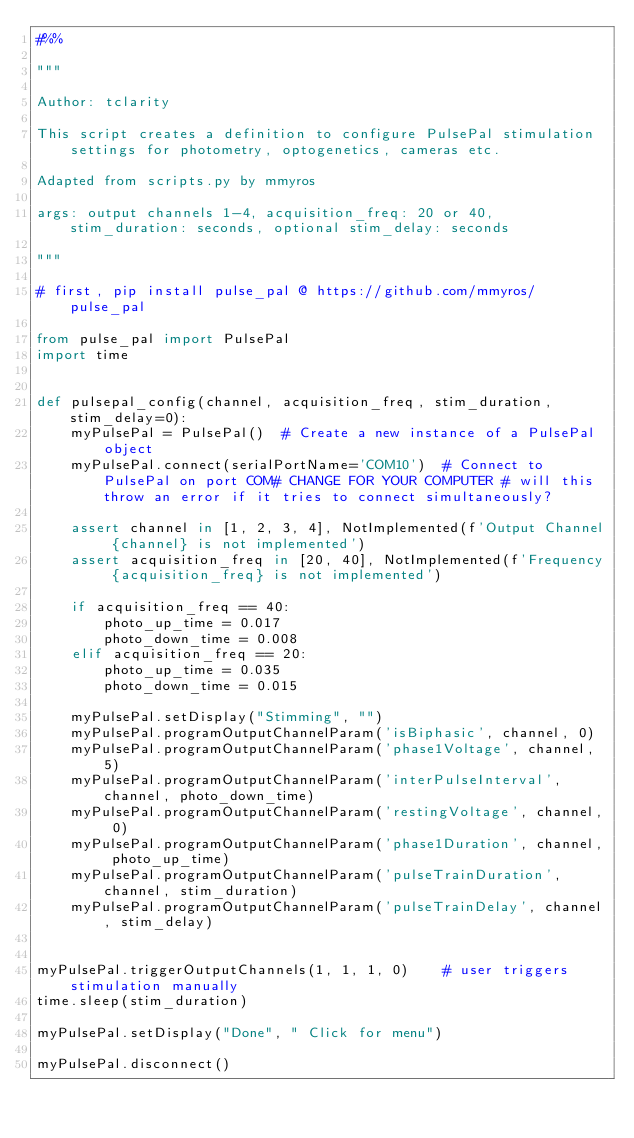<code> <loc_0><loc_0><loc_500><loc_500><_Python_>#%%

"""

Author: tclarity

This script creates a definition to configure PulsePal stimulation settings for photometry, optogenetics, cameras etc.

Adapted from scripts.py by mmyros

args: output channels 1-4, acquisition_freq: 20 or 40, stim_duration: seconds, optional stim_delay: seconds

"""

# first, pip install pulse_pal @ https://github.com/mmyros/pulse_pal

from pulse_pal import PulsePal
import time


def pulsepal_config(channel, acquisition_freq, stim_duration, stim_delay=0):
    myPulsePal = PulsePal()  # Create a new instance of a PulsePal object
    myPulsePal.connect(serialPortName='COM10')  # Connect to PulsePal on port COM# CHANGE FOR YOUR COMPUTER # will this throw an error if it tries to connect simultaneously?

    assert channel in [1, 2, 3, 4], NotImplemented(f'Output Channel {channel} is not implemented')
    assert acquisition_freq in [20, 40], NotImplemented(f'Frequency {acquisition_freq} is not implemented')

    if acquisition_freq == 40:
        photo_up_time = 0.017
        photo_down_time = 0.008
    elif acquisition_freq == 20:
        photo_up_time = 0.035
        photo_down_time = 0.015

    myPulsePal.setDisplay("Stimming", "")
    myPulsePal.programOutputChannelParam('isBiphasic', channel, 0)
    myPulsePal.programOutputChannelParam('phase1Voltage', channel, 5)
    myPulsePal.programOutputChannelParam('interPulseInterval', channel, photo_down_time)
    myPulsePal.programOutputChannelParam('restingVoltage', channel, 0)
    myPulsePal.programOutputChannelParam('phase1Duration', channel, photo_up_time)
    myPulsePal.programOutputChannelParam('pulseTrainDuration', channel, stim_duration)
    myPulsePal.programOutputChannelParam('pulseTrainDelay', channel, stim_delay)


myPulsePal.triggerOutputChannels(1, 1, 1, 0)    # user triggers stimulation manually
time.sleep(stim_duration)

myPulsePal.setDisplay("Done", " Click for menu")

myPulsePal.disconnect()
</code> 